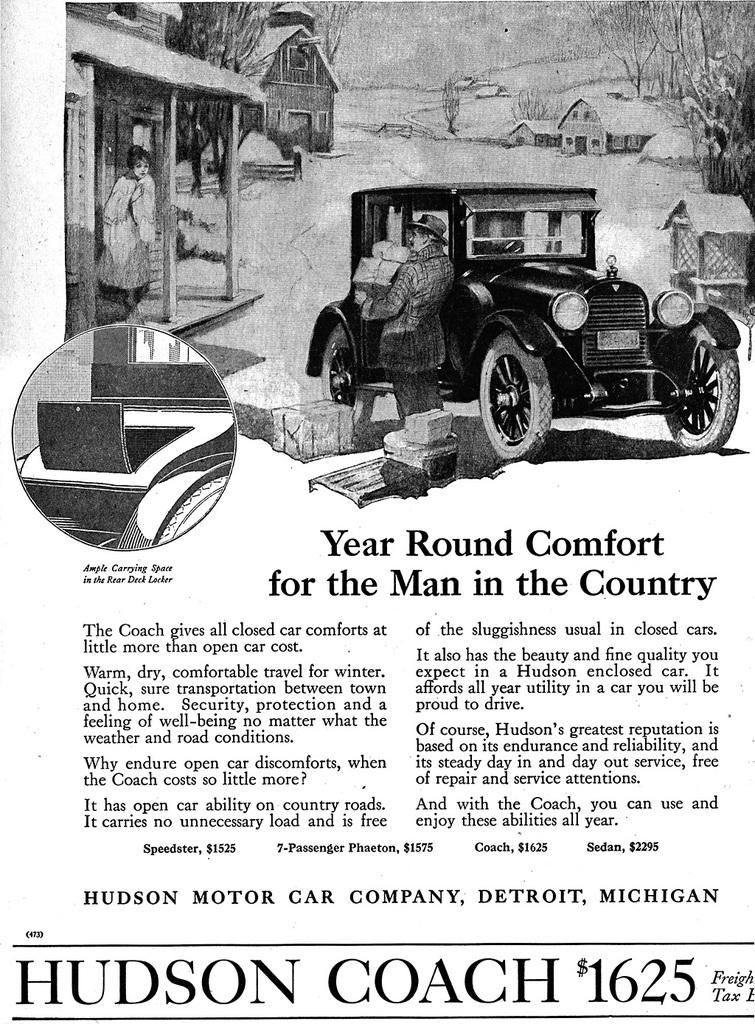What type of visual representation is shown in the image? The image is a poster. What types of objects are depicted in the poster? There are vehicles, houses, and trees in the poster. Are there any people in the poster? Yes, there are two people in the poster. Is there any text present in the poster? Yes, there is text in the poster. What is the sister of the boy doing in the poster? There is no mention of a sister or a boy in the poster, so this question cannot be answered. 